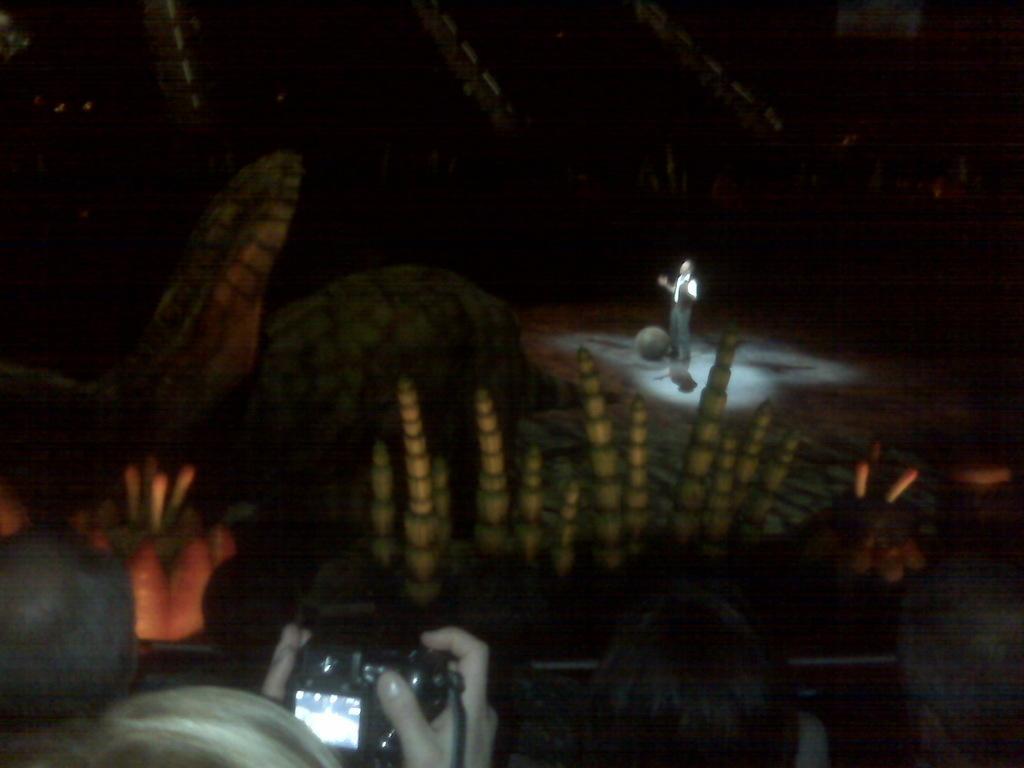In one or two sentences, can you explain what this image depicts? In this image, there is a man standing in the spot light, there are some people sitting, there is a person holding a camera. 